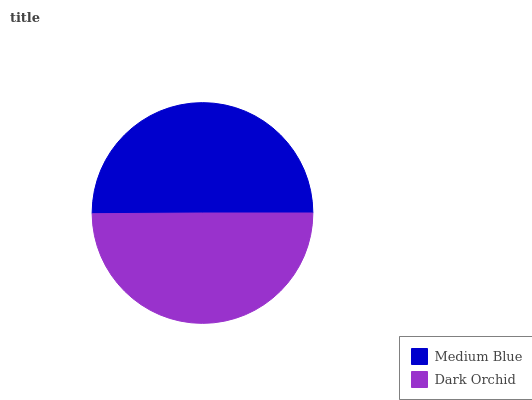Is Dark Orchid the minimum?
Answer yes or no. Yes. Is Medium Blue the maximum?
Answer yes or no. Yes. Is Dark Orchid the maximum?
Answer yes or no. No. Is Medium Blue greater than Dark Orchid?
Answer yes or no. Yes. Is Dark Orchid less than Medium Blue?
Answer yes or no. Yes. Is Dark Orchid greater than Medium Blue?
Answer yes or no. No. Is Medium Blue less than Dark Orchid?
Answer yes or no. No. Is Medium Blue the high median?
Answer yes or no. Yes. Is Dark Orchid the low median?
Answer yes or no. Yes. Is Dark Orchid the high median?
Answer yes or no. No. Is Medium Blue the low median?
Answer yes or no. No. 